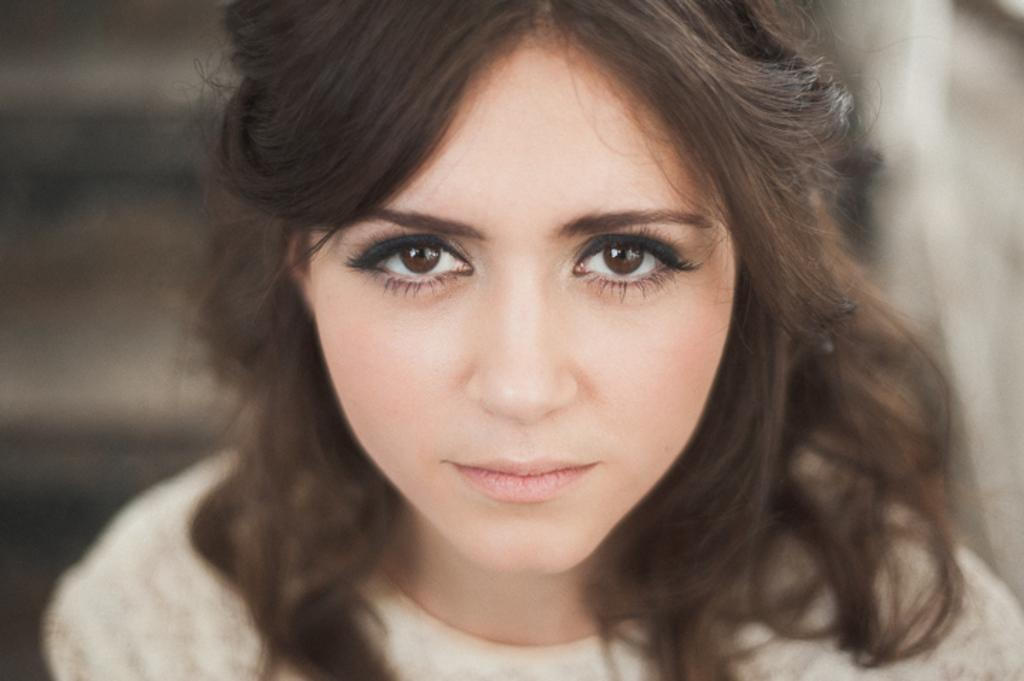Who is present in the image? There is a woman in the image. Can you describe the background of the image? The background of the image is blurred. What type of organization does the woman belong to in the image? There is no information about the woman's organization in the image. What is the woman's brain doing in the image? The image does not show the woman's brain, so it cannot be determined what her brain is doing. 